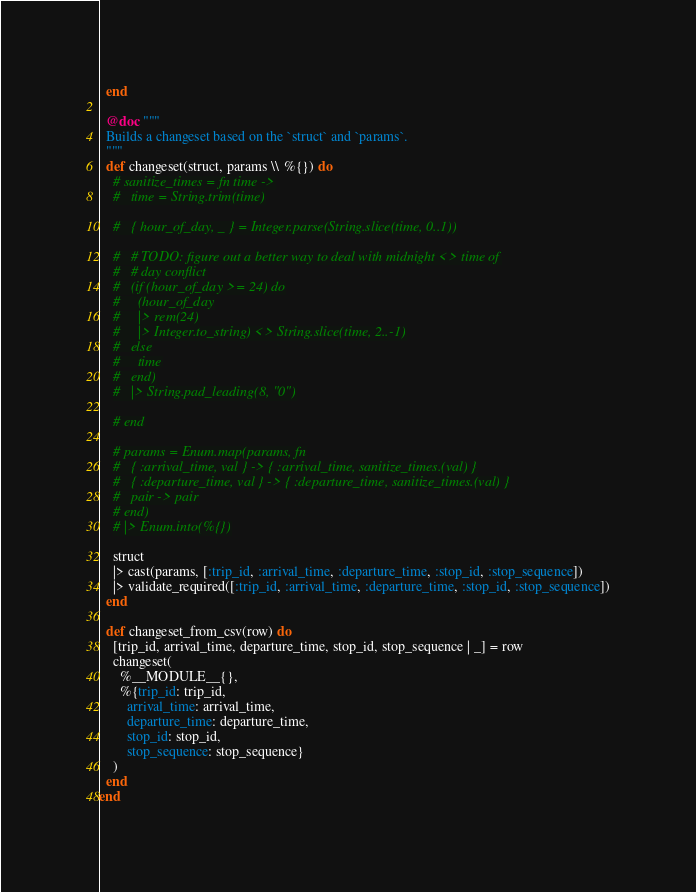<code> <loc_0><loc_0><loc_500><loc_500><_Elixir_>  end

  @doc """
  Builds a changeset based on the `struct` and `params`.
  """
  def changeset(struct, params \\ %{}) do
    # sanitize_times = fn time ->
    #   time = String.trim(time)

    #   { hour_of_day, _ } = Integer.parse(String.slice(time, 0..1))

    #   # TODO: figure out a better way to deal with midnight <> time of
    #   # day conflict
    #   (if (hour_of_day >= 24) do
    #     (hour_of_day
    #     |> rem(24)
    #     |> Integer.to_string) <> String.slice(time, 2..-1)
    #   else
    #     time
    #   end)
    #   |> String.pad_leading(8, "0")

    # end

    # params = Enum.map(params, fn
    #   { :arrival_time, val } -> { :arrival_time, sanitize_times.(val) }
    #   { :departure_time, val } -> { :departure_time, sanitize_times.(val) }
    #   pair -> pair
    # end)
    # |> Enum.into(%{})

    struct
    |> cast(params, [:trip_id, :arrival_time, :departure_time, :stop_id, :stop_sequence])
    |> validate_required([:trip_id, :arrival_time, :departure_time, :stop_id, :stop_sequence])
  end

  def changeset_from_csv(row) do
    [trip_id, arrival_time, departure_time, stop_id, stop_sequence | _] = row
    changeset(
      %__MODULE__{},
      %{trip_id: trip_id,
        arrival_time: arrival_time,
        departure_time: departure_time,
        stop_id: stop_id,
        stop_sequence: stop_sequence}
    )
  end
end
</code> 